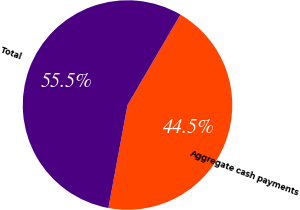Convert chart. <chart><loc_0><loc_0><loc_500><loc_500><pie_chart><fcel>Aggregate cash payments<fcel>Total<nl><fcel>44.5%<fcel>55.5%<nl></chart> 